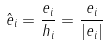<formula> <loc_0><loc_0><loc_500><loc_500>\hat { e } _ { i } = \frac { e _ { i } } { h _ { i } } = \frac { e _ { i } } { | e _ { i } | }</formula> 